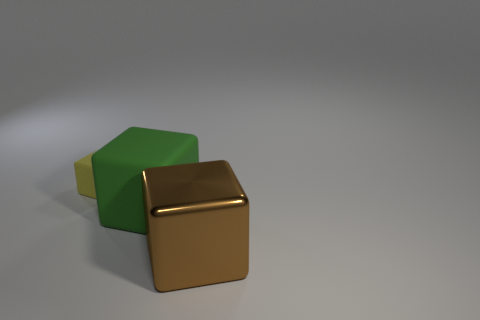Add 2 large yellow things. How many objects exist? 5 Subtract all large brown metallic blocks. Subtract all rubber cubes. How many objects are left? 0 Add 3 brown shiny cubes. How many brown shiny cubes are left? 4 Add 3 purple matte blocks. How many purple matte blocks exist? 3 Subtract 0 cyan spheres. How many objects are left? 3 